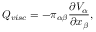<formula> <loc_0><loc_0><loc_500><loc_500>Q _ { v i s c } = - \pi _ { \alpha \beta } \frac { \partial V _ { \alpha } } { \partial x _ { \beta } } ,</formula> 